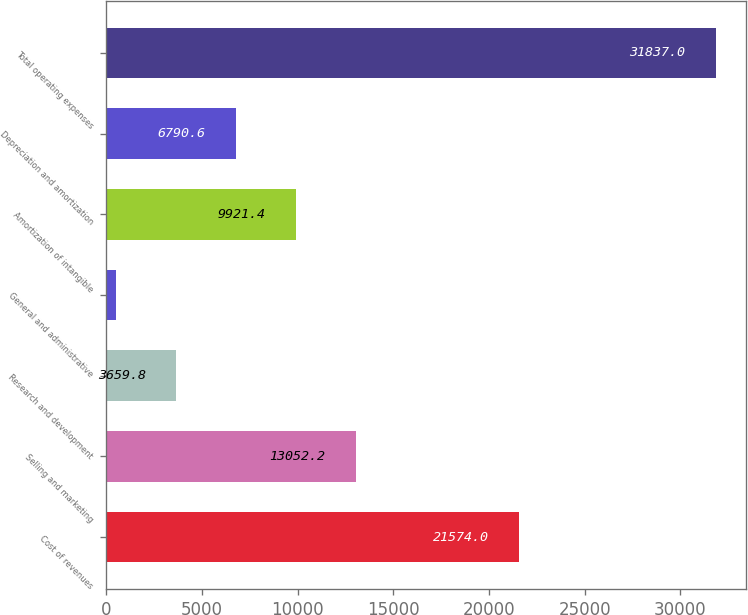<chart> <loc_0><loc_0><loc_500><loc_500><bar_chart><fcel>Cost of revenues<fcel>Selling and marketing<fcel>Research and development<fcel>General and administrative<fcel>Amortization of intangible<fcel>Depreciation and amortization<fcel>Total operating expenses<nl><fcel>21574<fcel>13052.2<fcel>3659.8<fcel>529<fcel>9921.4<fcel>6790.6<fcel>31837<nl></chart> 